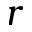<formula> <loc_0><loc_0><loc_500><loc_500>r</formula> 